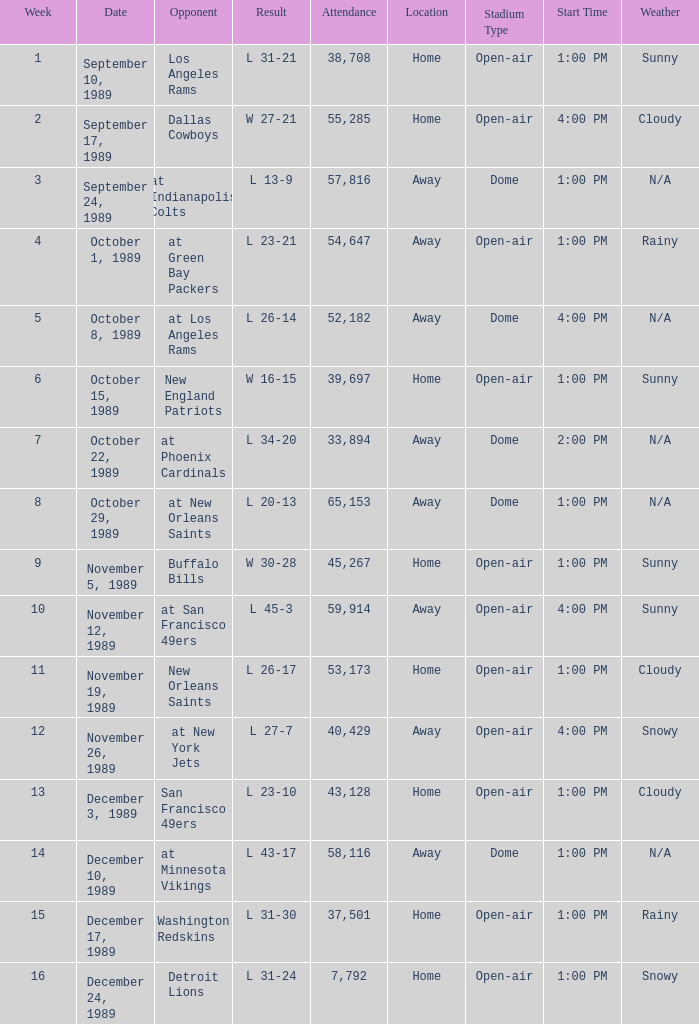Parse the table in full. {'header': ['Week', 'Date', 'Opponent', 'Result', 'Attendance', 'Location', 'Stadium Type', 'Start Time', 'Weather'], 'rows': [['1', 'September 10, 1989', 'Los Angeles Rams', 'L 31-21', '38,708', 'Home', 'Open-air', '1:00 PM', 'Sunny'], ['2', 'September 17, 1989', 'Dallas Cowboys', 'W 27-21', '55,285', 'Home', 'Open-air', '4:00 PM', 'Cloudy'], ['3', 'September 24, 1989', 'at Indianapolis Colts', 'L 13-9', '57,816', 'Away', 'Dome', '1:00 PM', 'N/A'], ['4', 'October 1, 1989', 'at Green Bay Packers', 'L 23-21', '54,647', 'Away', 'Open-air', '1:00 PM', 'Rainy'], ['5', 'October 8, 1989', 'at Los Angeles Rams', 'L 26-14', '52,182', 'Away', 'Dome', '4:00 PM', 'N/A'], ['6', 'October 15, 1989', 'New England Patriots', 'W 16-15', '39,697', 'Home', 'Open-air', '1:00 PM', 'Sunny'], ['7', 'October 22, 1989', 'at Phoenix Cardinals', 'L 34-20', '33,894', 'Away', 'Dome', '2:00 PM', 'N/A'], ['8', 'October 29, 1989', 'at New Orleans Saints', 'L 20-13', '65,153', 'Away', 'Dome', '1:00 PM', 'N/A'], ['9', 'November 5, 1989', 'Buffalo Bills', 'W 30-28', '45,267', 'Home', 'Open-air', '1:00 PM', 'Sunny'], ['10', 'November 12, 1989', 'at San Francisco 49ers', 'L 45-3', '59,914', 'Away', 'Open-air', '4:00 PM', 'Sunny'], ['11', 'November 19, 1989', 'New Orleans Saints', 'L 26-17', '53,173', 'Home', 'Open-air', '1:00 PM', 'Cloudy'], ['12', 'November 26, 1989', 'at New York Jets', 'L 27-7', '40,429', 'Away', 'Open-air', '4:00 PM', 'Snowy'], ['13', 'December 3, 1989', 'San Francisco 49ers', 'L 23-10', '43,128', 'Home', 'Open-air', '1:00 PM', 'Cloudy'], ['14', 'December 10, 1989', 'at Minnesota Vikings', 'L 43-17', '58,116', 'Away', 'Dome', '1:00 PM', 'N/A'], ['15', 'December 17, 1989', 'Washington Redskins', 'L 31-30', '37,501', 'Home', 'Open-air', '1:00 PM', 'Rainy'], ['16', 'December 24, 1989', 'Detroit Lions', 'L 31-24', '7,792', 'Home', 'Open-air', '1:00 PM', 'Snowy']]} On september 10, 1989, how many individuals were present at the match? 38708.0. 